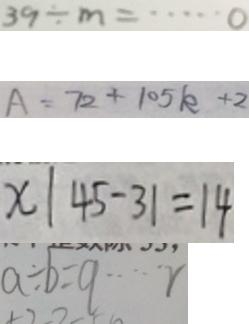<formula> <loc_0><loc_0><loc_500><loc_500>3 9 \div m = \cdots 0 
 A = 7 2 + 1 0 5 k + 2 
 x \vert 4 5 - 3 1 = 1 4 
 a \div b = q \cdots r</formula> 